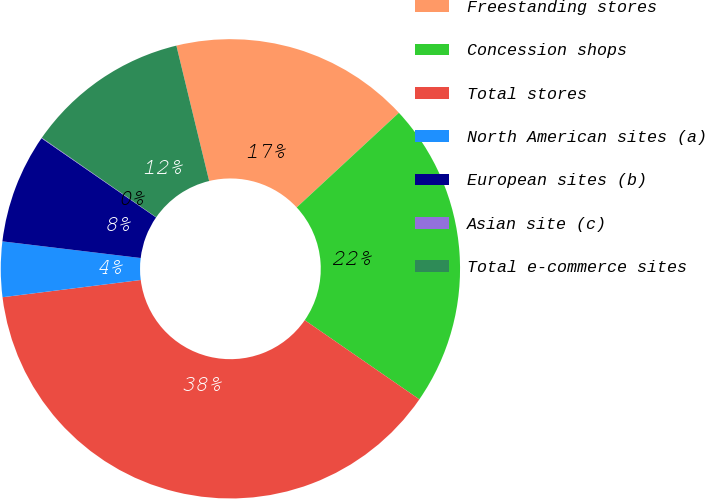<chart> <loc_0><loc_0><loc_500><loc_500><pie_chart><fcel>Freestanding stores<fcel>Concession shops<fcel>Total stores<fcel>North American sites (a)<fcel>European sites (b)<fcel>Asian site (c)<fcel>Total e-commerce sites<nl><fcel>16.89%<fcel>21.51%<fcel>38.4%<fcel>3.88%<fcel>7.72%<fcel>0.04%<fcel>11.55%<nl></chart> 